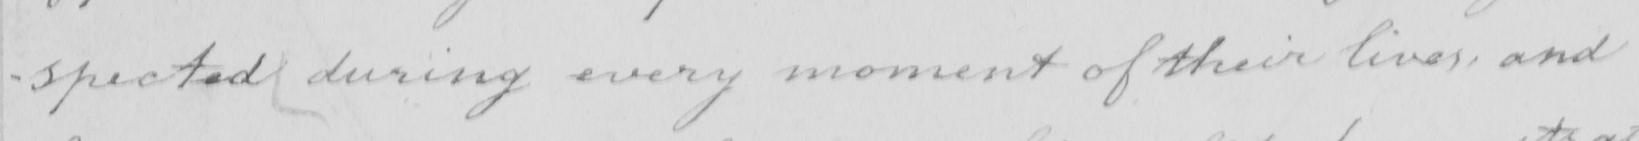What does this handwritten line say? -spected during every moment of their lives , and 